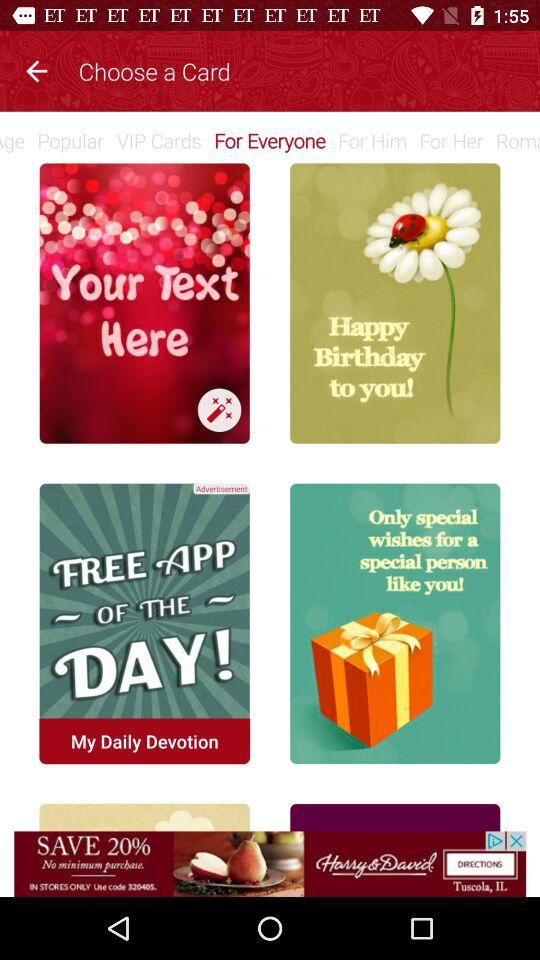Which category of choosing card am I in? You are in the "For Everyone" category of choosing the cards. 